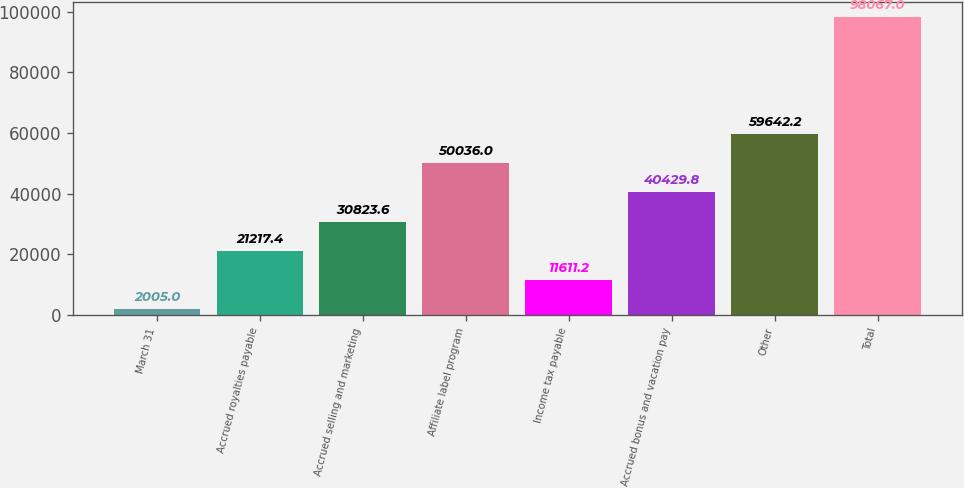Convert chart. <chart><loc_0><loc_0><loc_500><loc_500><bar_chart><fcel>March 31<fcel>Accrued royalties payable<fcel>Accrued selling and marketing<fcel>Affiliate label program<fcel>Income tax payable<fcel>Accrued bonus and vacation pay<fcel>Other<fcel>Total<nl><fcel>2005<fcel>21217.4<fcel>30823.6<fcel>50036<fcel>11611.2<fcel>40429.8<fcel>59642.2<fcel>98067<nl></chart> 